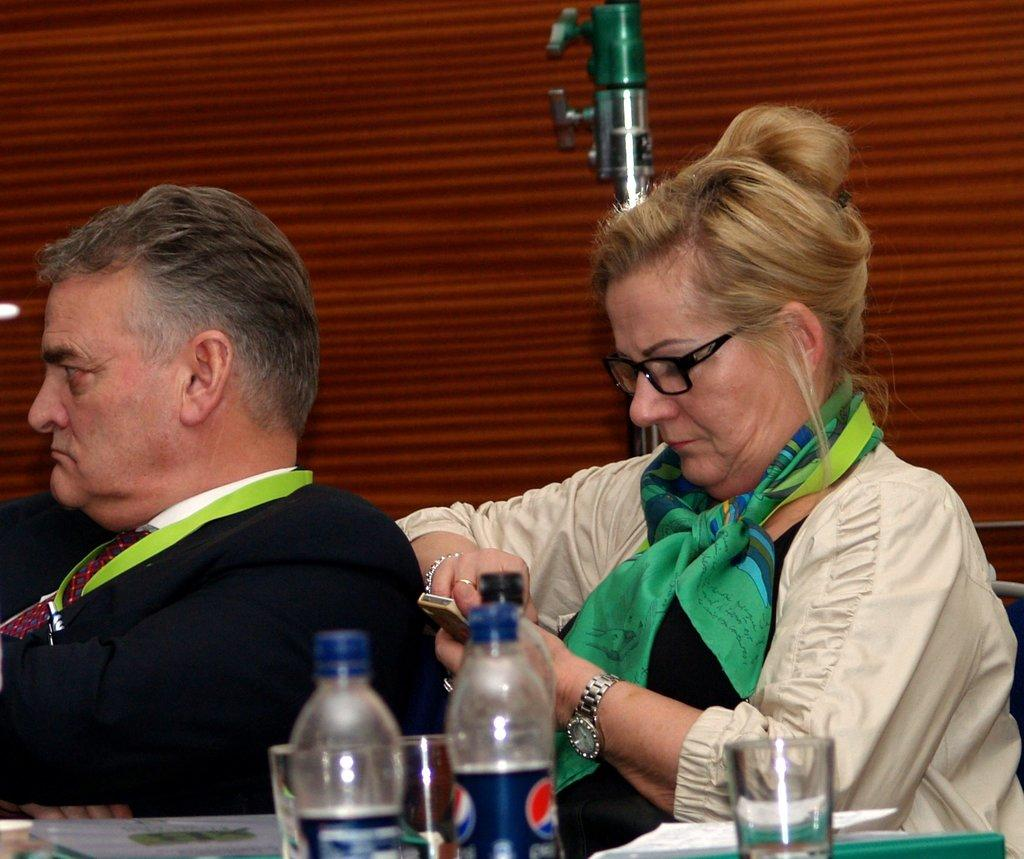How many people are present in the image? There is a man and a woman in the image. What objects can be seen on the table in the image? There are bottles with glasses on the table in the image. What type of account is being discussed by the man and woman in the image? There is no indication in the image that the man and woman are discussing any type of account. 